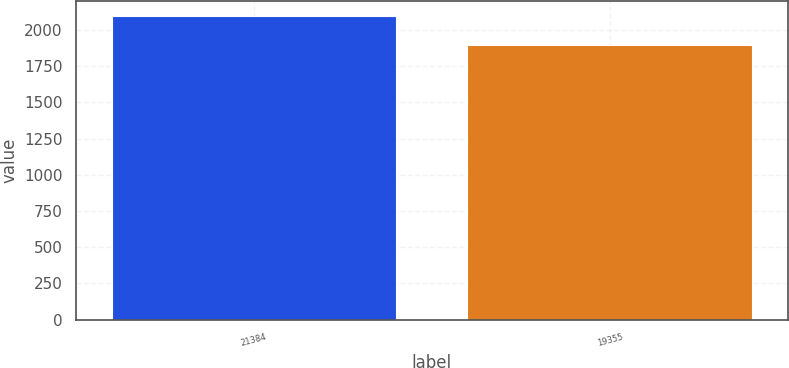<chart> <loc_0><loc_0><loc_500><loc_500><bar_chart><fcel>21384<fcel>19355<nl><fcel>2094.6<fcel>1896.4<nl></chart> 